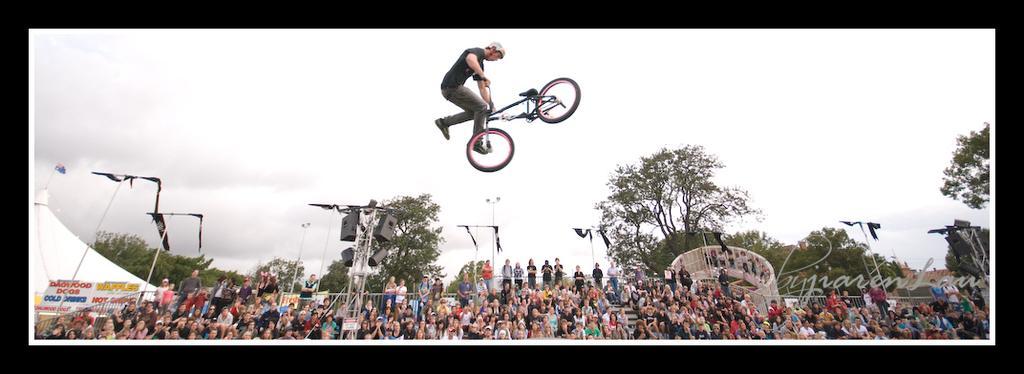Could you give a brief overview of what you see in this image? In this image we can see persons sitting on the stairs and some are standing. In the background we can see a person doing feats with the bicycle, iron grills, flags, speakers, street poles, street lights, trees and sky. 